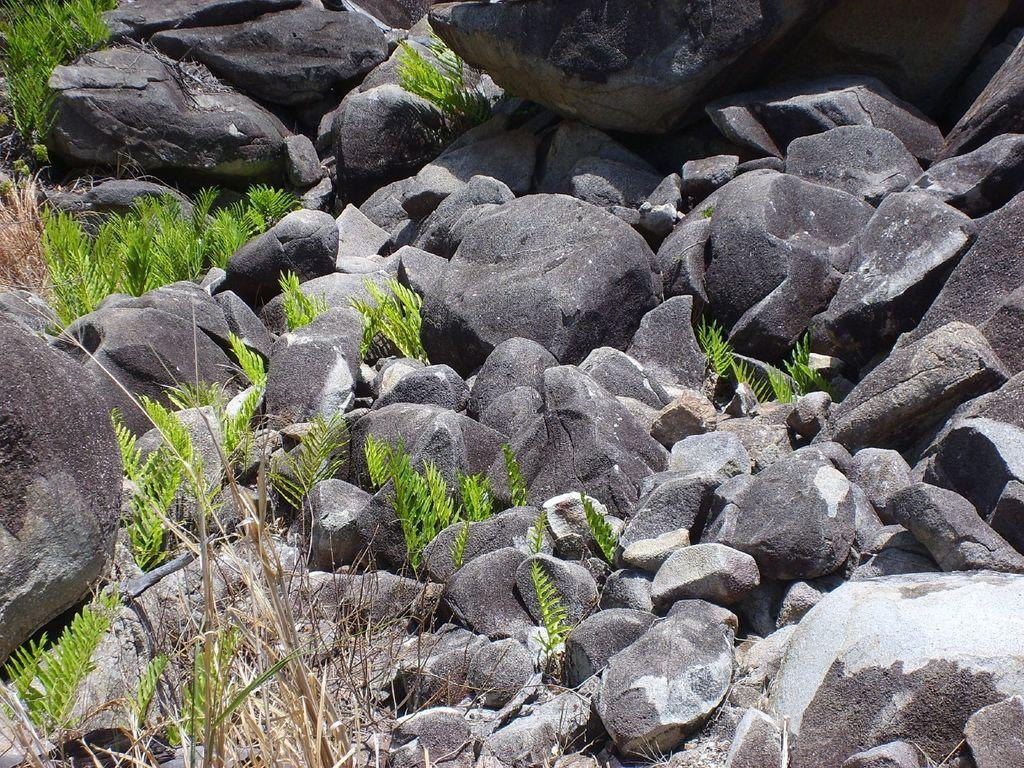Where was the image taken? The image was taken outdoors. What can be seen on the ground in the image? There are many rocks and stones on the ground. Are there any plants visible in the image? Yes, there are a few plants with green leaves in the image. How many steps does the person take in the image? There is no person visible in the image, so it is impossible to determine how many steps they might take. 